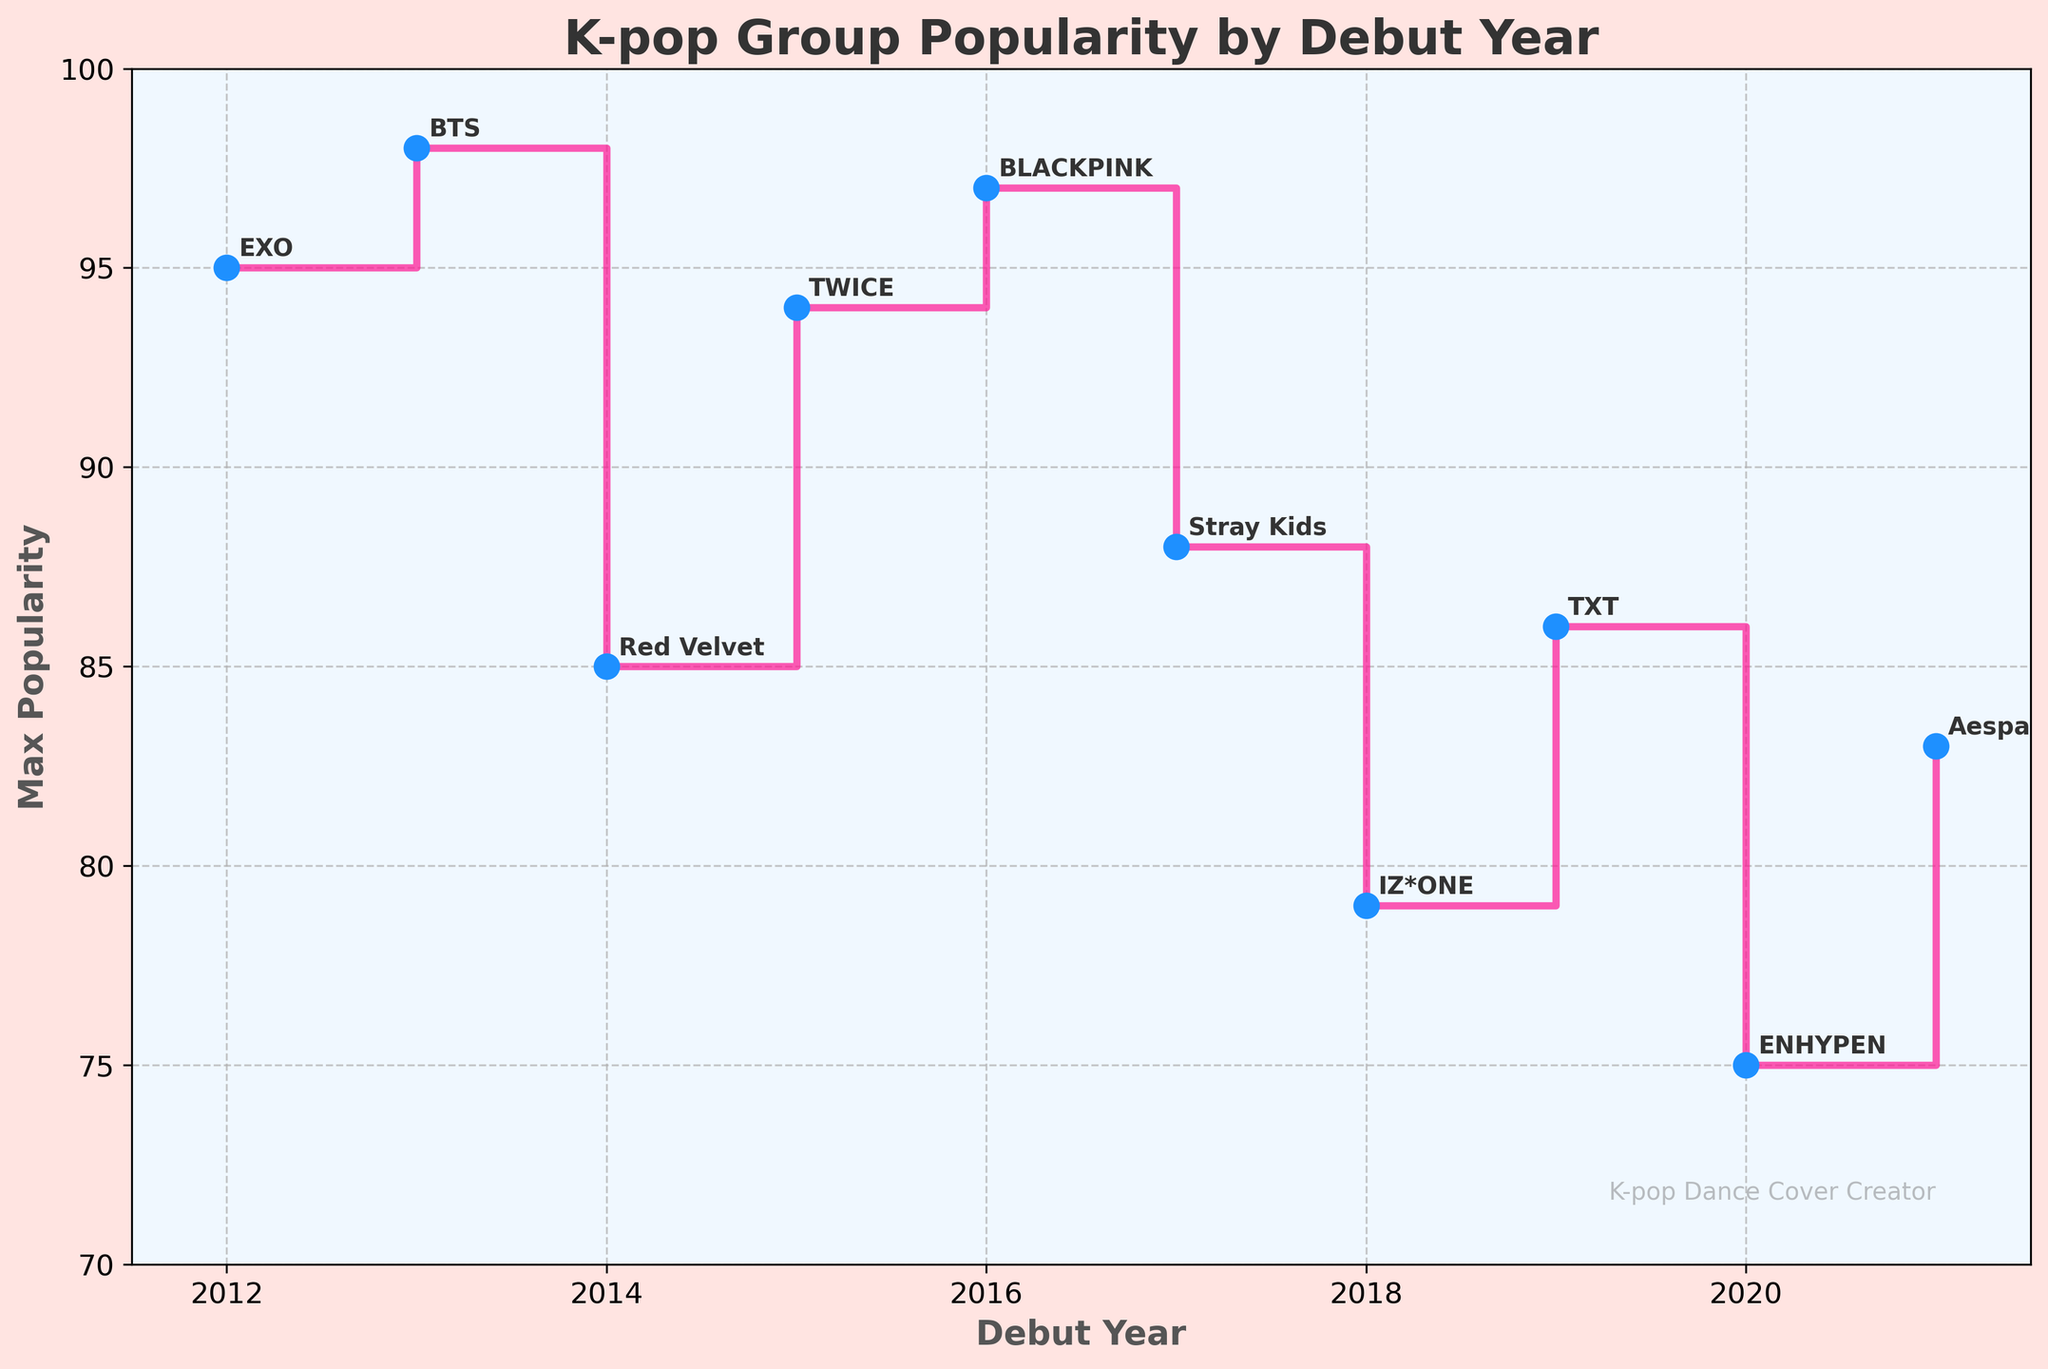What is the title of the figure? The title is displayed at the top of the figure. It reads, "K-pop Group Popularity by Debut Year."
Answer: K-pop Group Popularity by Debut Year What is the highest popularity score and which group achieved it? The highest point on the y-axis represents the maximum popularity score. The annotation indicates it is BTS in 2013 with a score of 98.
Answer: 98, BTS Between 2015 and 2017, which year saw the highest maximum popularity score? Looking at the steps, 2015 has a score of 94 (TWICE), 2016 has 97 (BLACKPINK), and 2017 has 88 (Stray Kids). Therefore, 2016 has the highest score.
Answer: 2016 How many debut years are represented in the figure? Count the unique points along the x-axis. They range from 2012 to 2021 inclusive.
Answer: 10 Which group represents the lowest maximum popularity score among the debut years, and what is the score? The lowest point in the stair plot is around 2020 with a score of 72, indicated by the annotation "TREASURE".
Answer: TREASURE, 72 What is the change in maximum popularity score from 2013 to 2014? From the stair plot, 2013 has a maximum popularity score of 98 (BTS) and 2014 has 85 (Red Velvet). The difference is 98 - 85.
Answer: 13 Which debut year has more than one group mentioned, and what are the groups? Reviewing the annotations, the year 2012 lists both EXO and B.A.P.
Answer: 2012, EXO and B.A.P Does the maximum popularity score show an increasing trend, decreasing trend, or fluctuating trend over the years? Observing the stair plot, the maxima do not consistently increase or decrease; they fluctuate over the years.
Answer: Fluctuating trend Between 2018 and 2020, what are the average maximum popularity scores? The maximum scores for the years are: 2018: 79 (IZ*ONE), 2019: 86 (TXT), and 2020: 75 (ENHYPEN). Average is (79+86+75)/3.
Answer: 80 How does the visual appearance of the plot emphasize K-pop themes? The plot uses bright colors like pink and blue and has a subtle K-pop themed background with a watermark emphasizing K-pop dance cover creation.
Answer: Bright colors and K-pop themed background 